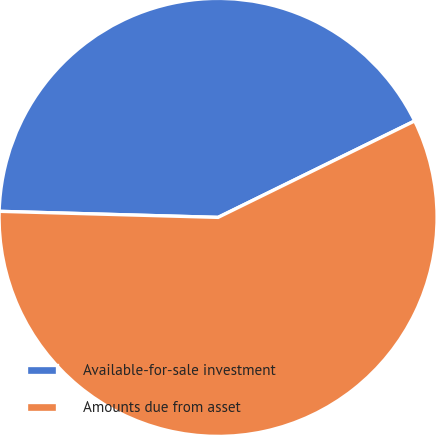Convert chart to OTSL. <chart><loc_0><loc_0><loc_500><loc_500><pie_chart><fcel>Available-for-sale investment<fcel>Amounts due from asset<nl><fcel>42.3%<fcel>57.7%<nl></chart> 